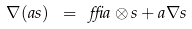Convert formula to latex. <formula><loc_0><loc_0><loc_500><loc_500>\nabla ( a s ) \ = \ \delta a \otimes s + a \nabla s</formula> 